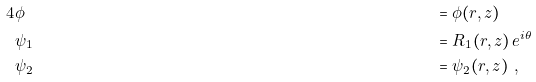<formula> <loc_0><loc_0><loc_500><loc_500>4 & \phi & & = \phi ( r , z ) \\ & \psi _ { 1 } & & = R _ { 1 } ( r , z ) \, e ^ { i \theta } \\ & \psi _ { 2 } & & = \psi _ { 2 } ( r , z ) \ ,</formula> 